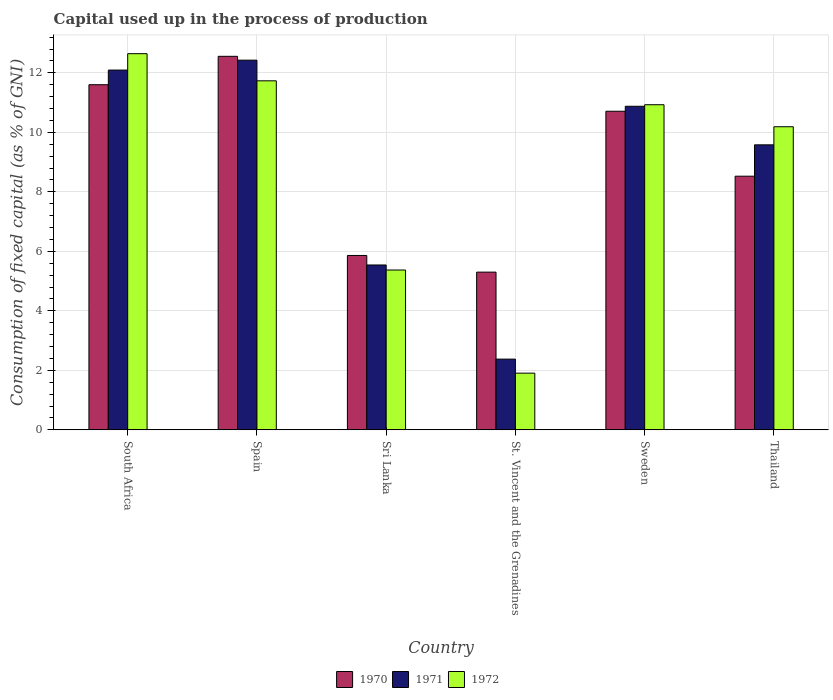How many different coloured bars are there?
Provide a succinct answer. 3. Are the number of bars per tick equal to the number of legend labels?
Ensure brevity in your answer.  Yes. Are the number of bars on each tick of the X-axis equal?
Your response must be concise. Yes. How many bars are there on the 3rd tick from the left?
Keep it short and to the point. 3. What is the label of the 1st group of bars from the left?
Provide a short and direct response. South Africa. In how many cases, is the number of bars for a given country not equal to the number of legend labels?
Your answer should be compact. 0. What is the capital used up in the process of production in 1971 in Sweden?
Give a very brief answer. 10.88. Across all countries, what is the maximum capital used up in the process of production in 1971?
Your answer should be compact. 12.43. Across all countries, what is the minimum capital used up in the process of production in 1970?
Ensure brevity in your answer.  5.3. In which country was the capital used up in the process of production in 1972 maximum?
Ensure brevity in your answer.  South Africa. In which country was the capital used up in the process of production in 1971 minimum?
Your response must be concise. St. Vincent and the Grenadines. What is the total capital used up in the process of production in 1971 in the graph?
Your response must be concise. 52.9. What is the difference between the capital used up in the process of production in 1972 in Spain and that in Thailand?
Give a very brief answer. 1.54. What is the difference between the capital used up in the process of production in 1971 in St. Vincent and the Grenadines and the capital used up in the process of production in 1972 in South Africa?
Your answer should be compact. -10.27. What is the average capital used up in the process of production in 1970 per country?
Your response must be concise. 9.09. What is the difference between the capital used up in the process of production of/in 1970 and capital used up in the process of production of/in 1972 in Sweden?
Offer a very short reply. -0.22. In how many countries, is the capital used up in the process of production in 1970 greater than 12.4 %?
Offer a terse response. 1. What is the ratio of the capital used up in the process of production in 1970 in Spain to that in Sweden?
Your answer should be very brief. 1.17. Is the difference between the capital used up in the process of production in 1970 in Sweden and Thailand greater than the difference between the capital used up in the process of production in 1972 in Sweden and Thailand?
Provide a succinct answer. Yes. What is the difference between the highest and the second highest capital used up in the process of production in 1972?
Provide a short and direct response. -0.8. What is the difference between the highest and the lowest capital used up in the process of production in 1970?
Ensure brevity in your answer.  7.26. What does the 2nd bar from the right in Sri Lanka represents?
Your answer should be compact. 1971. Is it the case that in every country, the sum of the capital used up in the process of production in 1970 and capital used up in the process of production in 1972 is greater than the capital used up in the process of production in 1971?
Ensure brevity in your answer.  Yes. Are all the bars in the graph horizontal?
Offer a very short reply. No. How many countries are there in the graph?
Ensure brevity in your answer.  6. What is the difference between two consecutive major ticks on the Y-axis?
Keep it short and to the point. 2. Where does the legend appear in the graph?
Your answer should be very brief. Bottom center. What is the title of the graph?
Your answer should be compact. Capital used up in the process of production. Does "1960" appear as one of the legend labels in the graph?
Make the answer very short. No. What is the label or title of the X-axis?
Offer a very short reply. Country. What is the label or title of the Y-axis?
Your answer should be very brief. Consumption of fixed capital (as % of GNI). What is the Consumption of fixed capital (as % of GNI) of 1970 in South Africa?
Keep it short and to the point. 11.6. What is the Consumption of fixed capital (as % of GNI) in 1971 in South Africa?
Your response must be concise. 12.09. What is the Consumption of fixed capital (as % of GNI) in 1972 in South Africa?
Provide a succinct answer. 12.65. What is the Consumption of fixed capital (as % of GNI) in 1970 in Spain?
Your response must be concise. 12.56. What is the Consumption of fixed capital (as % of GNI) of 1971 in Spain?
Offer a very short reply. 12.43. What is the Consumption of fixed capital (as % of GNI) in 1972 in Spain?
Provide a short and direct response. 11.73. What is the Consumption of fixed capital (as % of GNI) in 1970 in Sri Lanka?
Your answer should be compact. 5.86. What is the Consumption of fixed capital (as % of GNI) in 1971 in Sri Lanka?
Provide a succinct answer. 5.54. What is the Consumption of fixed capital (as % of GNI) in 1972 in Sri Lanka?
Provide a short and direct response. 5.37. What is the Consumption of fixed capital (as % of GNI) of 1970 in St. Vincent and the Grenadines?
Your answer should be compact. 5.3. What is the Consumption of fixed capital (as % of GNI) in 1971 in St. Vincent and the Grenadines?
Ensure brevity in your answer.  2.38. What is the Consumption of fixed capital (as % of GNI) in 1972 in St. Vincent and the Grenadines?
Your answer should be compact. 1.9. What is the Consumption of fixed capital (as % of GNI) of 1970 in Sweden?
Offer a terse response. 10.71. What is the Consumption of fixed capital (as % of GNI) of 1971 in Sweden?
Your answer should be compact. 10.88. What is the Consumption of fixed capital (as % of GNI) in 1972 in Sweden?
Ensure brevity in your answer.  10.93. What is the Consumption of fixed capital (as % of GNI) of 1970 in Thailand?
Offer a terse response. 8.53. What is the Consumption of fixed capital (as % of GNI) in 1971 in Thailand?
Your response must be concise. 9.58. What is the Consumption of fixed capital (as % of GNI) in 1972 in Thailand?
Keep it short and to the point. 10.19. Across all countries, what is the maximum Consumption of fixed capital (as % of GNI) of 1970?
Keep it short and to the point. 12.56. Across all countries, what is the maximum Consumption of fixed capital (as % of GNI) in 1971?
Provide a short and direct response. 12.43. Across all countries, what is the maximum Consumption of fixed capital (as % of GNI) of 1972?
Ensure brevity in your answer.  12.65. Across all countries, what is the minimum Consumption of fixed capital (as % of GNI) in 1970?
Your answer should be very brief. 5.3. Across all countries, what is the minimum Consumption of fixed capital (as % of GNI) in 1971?
Your answer should be compact. 2.38. Across all countries, what is the minimum Consumption of fixed capital (as % of GNI) in 1972?
Offer a terse response. 1.9. What is the total Consumption of fixed capital (as % of GNI) of 1970 in the graph?
Make the answer very short. 54.56. What is the total Consumption of fixed capital (as % of GNI) in 1971 in the graph?
Offer a terse response. 52.9. What is the total Consumption of fixed capital (as % of GNI) of 1972 in the graph?
Keep it short and to the point. 52.77. What is the difference between the Consumption of fixed capital (as % of GNI) of 1970 in South Africa and that in Spain?
Your answer should be very brief. -0.95. What is the difference between the Consumption of fixed capital (as % of GNI) of 1971 in South Africa and that in Spain?
Ensure brevity in your answer.  -0.33. What is the difference between the Consumption of fixed capital (as % of GNI) in 1972 in South Africa and that in Spain?
Make the answer very short. 0.91. What is the difference between the Consumption of fixed capital (as % of GNI) in 1970 in South Africa and that in Sri Lanka?
Ensure brevity in your answer.  5.74. What is the difference between the Consumption of fixed capital (as % of GNI) of 1971 in South Africa and that in Sri Lanka?
Offer a terse response. 6.55. What is the difference between the Consumption of fixed capital (as % of GNI) of 1972 in South Africa and that in Sri Lanka?
Keep it short and to the point. 7.27. What is the difference between the Consumption of fixed capital (as % of GNI) in 1970 in South Africa and that in St. Vincent and the Grenadines?
Offer a very short reply. 6.3. What is the difference between the Consumption of fixed capital (as % of GNI) of 1971 in South Africa and that in St. Vincent and the Grenadines?
Offer a very short reply. 9.72. What is the difference between the Consumption of fixed capital (as % of GNI) of 1972 in South Africa and that in St. Vincent and the Grenadines?
Provide a succinct answer. 10.74. What is the difference between the Consumption of fixed capital (as % of GNI) in 1970 in South Africa and that in Sweden?
Your answer should be compact. 0.89. What is the difference between the Consumption of fixed capital (as % of GNI) in 1971 in South Africa and that in Sweden?
Provide a short and direct response. 1.22. What is the difference between the Consumption of fixed capital (as % of GNI) of 1972 in South Africa and that in Sweden?
Keep it short and to the point. 1.72. What is the difference between the Consumption of fixed capital (as % of GNI) of 1970 in South Africa and that in Thailand?
Provide a succinct answer. 3.08. What is the difference between the Consumption of fixed capital (as % of GNI) in 1971 in South Africa and that in Thailand?
Keep it short and to the point. 2.51. What is the difference between the Consumption of fixed capital (as % of GNI) of 1972 in South Africa and that in Thailand?
Your answer should be very brief. 2.46. What is the difference between the Consumption of fixed capital (as % of GNI) of 1970 in Spain and that in Sri Lanka?
Make the answer very short. 6.7. What is the difference between the Consumption of fixed capital (as % of GNI) in 1971 in Spain and that in Sri Lanka?
Make the answer very short. 6.89. What is the difference between the Consumption of fixed capital (as % of GNI) of 1972 in Spain and that in Sri Lanka?
Provide a short and direct response. 6.36. What is the difference between the Consumption of fixed capital (as % of GNI) of 1970 in Spain and that in St. Vincent and the Grenadines?
Offer a terse response. 7.26. What is the difference between the Consumption of fixed capital (as % of GNI) of 1971 in Spain and that in St. Vincent and the Grenadines?
Provide a short and direct response. 10.05. What is the difference between the Consumption of fixed capital (as % of GNI) in 1972 in Spain and that in St. Vincent and the Grenadines?
Your answer should be very brief. 9.83. What is the difference between the Consumption of fixed capital (as % of GNI) in 1970 in Spain and that in Sweden?
Your answer should be very brief. 1.85. What is the difference between the Consumption of fixed capital (as % of GNI) of 1971 in Spain and that in Sweden?
Give a very brief answer. 1.55. What is the difference between the Consumption of fixed capital (as % of GNI) in 1972 in Spain and that in Sweden?
Give a very brief answer. 0.8. What is the difference between the Consumption of fixed capital (as % of GNI) of 1970 in Spain and that in Thailand?
Provide a short and direct response. 4.03. What is the difference between the Consumption of fixed capital (as % of GNI) of 1971 in Spain and that in Thailand?
Make the answer very short. 2.85. What is the difference between the Consumption of fixed capital (as % of GNI) of 1972 in Spain and that in Thailand?
Give a very brief answer. 1.54. What is the difference between the Consumption of fixed capital (as % of GNI) in 1970 in Sri Lanka and that in St. Vincent and the Grenadines?
Make the answer very short. 0.56. What is the difference between the Consumption of fixed capital (as % of GNI) in 1971 in Sri Lanka and that in St. Vincent and the Grenadines?
Offer a terse response. 3.16. What is the difference between the Consumption of fixed capital (as % of GNI) of 1972 in Sri Lanka and that in St. Vincent and the Grenadines?
Keep it short and to the point. 3.47. What is the difference between the Consumption of fixed capital (as % of GNI) in 1970 in Sri Lanka and that in Sweden?
Your response must be concise. -4.85. What is the difference between the Consumption of fixed capital (as % of GNI) in 1971 in Sri Lanka and that in Sweden?
Offer a very short reply. -5.34. What is the difference between the Consumption of fixed capital (as % of GNI) in 1972 in Sri Lanka and that in Sweden?
Your response must be concise. -5.56. What is the difference between the Consumption of fixed capital (as % of GNI) of 1970 in Sri Lanka and that in Thailand?
Provide a succinct answer. -2.67. What is the difference between the Consumption of fixed capital (as % of GNI) in 1971 in Sri Lanka and that in Thailand?
Your answer should be very brief. -4.04. What is the difference between the Consumption of fixed capital (as % of GNI) in 1972 in Sri Lanka and that in Thailand?
Make the answer very short. -4.82. What is the difference between the Consumption of fixed capital (as % of GNI) in 1970 in St. Vincent and the Grenadines and that in Sweden?
Keep it short and to the point. -5.41. What is the difference between the Consumption of fixed capital (as % of GNI) of 1971 in St. Vincent and the Grenadines and that in Sweden?
Your response must be concise. -8.5. What is the difference between the Consumption of fixed capital (as % of GNI) of 1972 in St. Vincent and the Grenadines and that in Sweden?
Offer a terse response. -9.02. What is the difference between the Consumption of fixed capital (as % of GNI) of 1970 in St. Vincent and the Grenadines and that in Thailand?
Ensure brevity in your answer.  -3.23. What is the difference between the Consumption of fixed capital (as % of GNI) of 1971 in St. Vincent and the Grenadines and that in Thailand?
Your answer should be very brief. -7.2. What is the difference between the Consumption of fixed capital (as % of GNI) in 1972 in St. Vincent and the Grenadines and that in Thailand?
Keep it short and to the point. -8.28. What is the difference between the Consumption of fixed capital (as % of GNI) of 1970 in Sweden and that in Thailand?
Provide a short and direct response. 2.18. What is the difference between the Consumption of fixed capital (as % of GNI) in 1971 in Sweden and that in Thailand?
Provide a succinct answer. 1.3. What is the difference between the Consumption of fixed capital (as % of GNI) of 1972 in Sweden and that in Thailand?
Your answer should be very brief. 0.74. What is the difference between the Consumption of fixed capital (as % of GNI) of 1970 in South Africa and the Consumption of fixed capital (as % of GNI) of 1971 in Spain?
Make the answer very short. -0.83. What is the difference between the Consumption of fixed capital (as % of GNI) of 1970 in South Africa and the Consumption of fixed capital (as % of GNI) of 1972 in Spain?
Ensure brevity in your answer.  -0.13. What is the difference between the Consumption of fixed capital (as % of GNI) in 1971 in South Africa and the Consumption of fixed capital (as % of GNI) in 1972 in Spain?
Your response must be concise. 0.36. What is the difference between the Consumption of fixed capital (as % of GNI) of 1970 in South Africa and the Consumption of fixed capital (as % of GNI) of 1971 in Sri Lanka?
Offer a terse response. 6.06. What is the difference between the Consumption of fixed capital (as % of GNI) in 1970 in South Africa and the Consumption of fixed capital (as % of GNI) in 1972 in Sri Lanka?
Provide a succinct answer. 6.23. What is the difference between the Consumption of fixed capital (as % of GNI) of 1971 in South Africa and the Consumption of fixed capital (as % of GNI) of 1972 in Sri Lanka?
Your answer should be compact. 6.72. What is the difference between the Consumption of fixed capital (as % of GNI) in 1970 in South Africa and the Consumption of fixed capital (as % of GNI) in 1971 in St. Vincent and the Grenadines?
Offer a very short reply. 9.23. What is the difference between the Consumption of fixed capital (as % of GNI) in 1970 in South Africa and the Consumption of fixed capital (as % of GNI) in 1972 in St. Vincent and the Grenadines?
Provide a succinct answer. 9.7. What is the difference between the Consumption of fixed capital (as % of GNI) of 1971 in South Africa and the Consumption of fixed capital (as % of GNI) of 1972 in St. Vincent and the Grenadines?
Offer a very short reply. 10.19. What is the difference between the Consumption of fixed capital (as % of GNI) in 1970 in South Africa and the Consumption of fixed capital (as % of GNI) in 1971 in Sweden?
Your answer should be very brief. 0.72. What is the difference between the Consumption of fixed capital (as % of GNI) of 1970 in South Africa and the Consumption of fixed capital (as % of GNI) of 1972 in Sweden?
Ensure brevity in your answer.  0.67. What is the difference between the Consumption of fixed capital (as % of GNI) in 1971 in South Africa and the Consumption of fixed capital (as % of GNI) in 1972 in Sweden?
Give a very brief answer. 1.17. What is the difference between the Consumption of fixed capital (as % of GNI) of 1970 in South Africa and the Consumption of fixed capital (as % of GNI) of 1971 in Thailand?
Your answer should be compact. 2.02. What is the difference between the Consumption of fixed capital (as % of GNI) in 1970 in South Africa and the Consumption of fixed capital (as % of GNI) in 1972 in Thailand?
Offer a terse response. 1.41. What is the difference between the Consumption of fixed capital (as % of GNI) in 1971 in South Africa and the Consumption of fixed capital (as % of GNI) in 1972 in Thailand?
Your response must be concise. 1.91. What is the difference between the Consumption of fixed capital (as % of GNI) of 1970 in Spain and the Consumption of fixed capital (as % of GNI) of 1971 in Sri Lanka?
Give a very brief answer. 7.01. What is the difference between the Consumption of fixed capital (as % of GNI) in 1970 in Spain and the Consumption of fixed capital (as % of GNI) in 1972 in Sri Lanka?
Make the answer very short. 7.18. What is the difference between the Consumption of fixed capital (as % of GNI) in 1971 in Spain and the Consumption of fixed capital (as % of GNI) in 1972 in Sri Lanka?
Provide a succinct answer. 7.06. What is the difference between the Consumption of fixed capital (as % of GNI) of 1970 in Spain and the Consumption of fixed capital (as % of GNI) of 1971 in St. Vincent and the Grenadines?
Ensure brevity in your answer.  10.18. What is the difference between the Consumption of fixed capital (as % of GNI) in 1970 in Spain and the Consumption of fixed capital (as % of GNI) in 1972 in St. Vincent and the Grenadines?
Keep it short and to the point. 10.65. What is the difference between the Consumption of fixed capital (as % of GNI) in 1971 in Spain and the Consumption of fixed capital (as % of GNI) in 1972 in St. Vincent and the Grenadines?
Your answer should be compact. 10.52. What is the difference between the Consumption of fixed capital (as % of GNI) in 1970 in Spain and the Consumption of fixed capital (as % of GNI) in 1971 in Sweden?
Give a very brief answer. 1.68. What is the difference between the Consumption of fixed capital (as % of GNI) in 1970 in Spain and the Consumption of fixed capital (as % of GNI) in 1972 in Sweden?
Offer a terse response. 1.63. What is the difference between the Consumption of fixed capital (as % of GNI) in 1971 in Spain and the Consumption of fixed capital (as % of GNI) in 1972 in Sweden?
Give a very brief answer. 1.5. What is the difference between the Consumption of fixed capital (as % of GNI) of 1970 in Spain and the Consumption of fixed capital (as % of GNI) of 1971 in Thailand?
Offer a terse response. 2.98. What is the difference between the Consumption of fixed capital (as % of GNI) of 1970 in Spain and the Consumption of fixed capital (as % of GNI) of 1972 in Thailand?
Your response must be concise. 2.37. What is the difference between the Consumption of fixed capital (as % of GNI) of 1971 in Spain and the Consumption of fixed capital (as % of GNI) of 1972 in Thailand?
Make the answer very short. 2.24. What is the difference between the Consumption of fixed capital (as % of GNI) in 1970 in Sri Lanka and the Consumption of fixed capital (as % of GNI) in 1971 in St. Vincent and the Grenadines?
Your answer should be very brief. 3.48. What is the difference between the Consumption of fixed capital (as % of GNI) in 1970 in Sri Lanka and the Consumption of fixed capital (as % of GNI) in 1972 in St. Vincent and the Grenadines?
Provide a succinct answer. 3.96. What is the difference between the Consumption of fixed capital (as % of GNI) in 1971 in Sri Lanka and the Consumption of fixed capital (as % of GNI) in 1972 in St. Vincent and the Grenadines?
Your response must be concise. 3.64. What is the difference between the Consumption of fixed capital (as % of GNI) of 1970 in Sri Lanka and the Consumption of fixed capital (as % of GNI) of 1971 in Sweden?
Your answer should be compact. -5.02. What is the difference between the Consumption of fixed capital (as % of GNI) of 1970 in Sri Lanka and the Consumption of fixed capital (as % of GNI) of 1972 in Sweden?
Your response must be concise. -5.07. What is the difference between the Consumption of fixed capital (as % of GNI) in 1971 in Sri Lanka and the Consumption of fixed capital (as % of GNI) in 1972 in Sweden?
Your answer should be compact. -5.39. What is the difference between the Consumption of fixed capital (as % of GNI) of 1970 in Sri Lanka and the Consumption of fixed capital (as % of GNI) of 1971 in Thailand?
Keep it short and to the point. -3.72. What is the difference between the Consumption of fixed capital (as % of GNI) of 1970 in Sri Lanka and the Consumption of fixed capital (as % of GNI) of 1972 in Thailand?
Offer a very short reply. -4.33. What is the difference between the Consumption of fixed capital (as % of GNI) in 1971 in Sri Lanka and the Consumption of fixed capital (as % of GNI) in 1972 in Thailand?
Your answer should be very brief. -4.65. What is the difference between the Consumption of fixed capital (as % of GNI) in 1970 in St. Vincent and the Grenadines and the Consumption of fixed capital (as % of GNI) in 1971 in Sweden?
Your answer should be compact. -5.58. What is the difference between the Consumption of fixed capital (as % of GNI) in 1970 in St. Vincent and the Grenadines and the Consumption of fixed capital (as % of GNI) in 1972 in Sweden?
Provide a short and direct response. -5.63. What is the difference between the Consumption of fixed capital (as % of GNI) in 1971 in St. Vincent and the Grenadines and the Consumption of fixed capital (as % of GNI) in 1972 in Sweden?
Offer a very short reply. -8.55. What is the difference between the Consumption of fixed capital (as % of GNI) of 1970 in St. Vincent and the Grenadines and the Consumption of fixed capital (as % of GNI) of 1971 in Thailand?
Provide a succinct answer. -4.28. What is the difference between the Consumption of fixed capital (as % of GNI) in 1970 in St. Vincent and the Grenadines and the Consumption of fixed capital (as % of GNI) in 1972 in Thailand?
Provide a short and direct response. -4.89. What is the difference between the Consumption of fixed capital (as % of GNI) of 1971 in St. Vincent and the Grenadines and the Consumption of fixed capital (as % of GNI) of 1972 in Thailand?
Keep it short and to the point. -7.81. What is the difference between the Consumption of fixed capital (as % of GNI) in 1970 in Sweden and the Consumption of fixed capital (as % of GNI) in 1971 in Thailand?
Your response must be concise. 1.13. What is the difference between the Consumption of fixed capital (as % of GNI) in 1970 in Sweden and the Consumption of fixed capital (as % of GNI) in 1972 in Thailand?
Provide a short and direct response. 0.52. What is the difference between the Consumption of fixed capital (as % of GNI) of 1971 in Sweden and the Consumption of fixed capital (as % of GNI) of 1972 in Thailand?
Your answer should be compact. 0.69. What is the average Consumption of fixed capital (as % of GNI) of 1970 per country?
Offer a terse response. 9.09. What is the average Consumption of fixed capital (as % of GNI) of 1971 per country?
Provide a short and direct response. 8.82. What is the average Consumption of fixed capital (as % of GNI) of 1972 per country?
Provide a short and direct response. 8.8. What is the difference between the Consumption of fixed capital (as % of GNI) in 1970 and Consumption of fixed capital (as % of GNI) in 1971 in South Africa?
Offer a very short reply. -0.49. What is the difference between the Consumption of fixed capital (as % of GNI) of 1970 and Consumption of fixed capital (as % of GNI) of 1972 in South Africa?
Keep it short and to the point. -1.04. What is the difference between the Consumption of fixed capital (as % of GNI) of 1971 and Consumption of fixed capital (as % of GNI) of 1972 in South Africa?
Provide a short and direct response. -0.55. What is the difference between the Consumption of fixed capital (as % of GNI) of 1970 and Consumption of fixed capital (as % of GNI) of 1971 in Spain?
Your answer should be compact. 0.13. What is the difference between the Consumption of fixed capital (as % of GNI) in 1970 and Consumption of fixed capital (as % of GNI) in 1972 in Spain?
Your response must be concise. 0.82. What is the difference between the Consumption of fixed capital (as % of GNI) of 1971 and Consumption of fixed capital (as % of GNI) of 1972 in Spain?
Provide a succinct answer. 0.69. What is the difference between the Consumption of fixed capital (as % of GNI) in 1970 and Consumption of fixed capital (as % of GNI) in 1971 in Sri Lanka?
Keep it short and to the point. 0.32. What is the difference between the Consumption of fixed capital (as % of GNI) of 1970 and Consumption of fixed capital (as % of GNI) of 1972 in Sri Lanka?
Your response must be concise. 0.49. What is the difference between the Consumption of fixed capital (as % of GNI) in 1971 and Consumption of fixed capital (as % of GNI) in 1972 in Sri Lanka?
Provide a short and direct response. 0.17. What is the difference between the Consumption of fixed capital (as % of GNI) of 1970 and Consumption of fixed capital (as % of GNI) of 1971 in St. Vincent and the Grenadines?
Ensure brevity in your answer.  2.92. What is the difference between the Consumption of fixed capital (as % of GNI) of 1970 and Consumption of fixed capital (as % of GNI) of 1972 in St. Vincent and the Grenadines?
Provide a short and direct response. 3.4. What is the difference between the Consumption of fixed capital (as % of GNI) of 1971 and Consumption of fixed capital (as % of GNI) of 1972 in St. Vincent and the Grenadines?
Your response must be concise. 0.47. What is the difference between the Consumption of fixed capital (as % of GNI) in 1970 and Consumption of fixed capital (as % of GNI) in 1971 in Sweden?
Make the answer very short. -0.17. What is the difference between the Consumption of fixed capital (as % of GNI) of 1970 and Consumption of fixed capital (as % of GNI) of 1972 in Sweden?
Your answer should be very brief. -0.22. What is the difference between the Consumption of fixed capital (as % of GNI) of 1971 and Consumption of fixed capital (as % of GNI) of 1972 in Sweden?
Your answer should be very brief. -0.05. What is the difference between the Consumption of fixed capital (as % of GNI) in 1970 and Consumption of fixed capital (as % of GNI) in 1971 in Thailand?
Ensure brevity in your answer.  -1.05. What is the difference between the Consumption of fixed capital (as % of GNI) in 1970 and Consumption of fixed capital (as % of GNI) in 1972 in Thailand?
Your answer should be compact. -1.66. What is the difference between the Consumption of fixed capital (as % of GNI) of 1971 and Consumption of fixed capital (as % of GNI) of 1972 in Thailand?
Ensure brevity in your answer.  -0.61. What is the ratio of the Consumption of fixed capital (as % of GNI) in 1970 in South Africa to that in Spain?
Ensure brevity in your answer.  0.92. What is the ratio of the Consumption of fixed capital (as % of GNI) in 1971 in South Africa to that in Spain?
Keep it short and to the point. 0.97. What is the ratio of the Consumption of fixed capital (as % of GNI) of 1972 in South Africa to that in Spain?
Make the answer very short. 1.08. What is the ratio of the Consumption of fixed capital (as % of GNI) of 1970 in South Africa to that in Sri Lanka?
Offer a terse response. 1.98. What is the ratio of the Consumption of fixed capital (as % of GNI) of 1971 in South Africa to that in Sri Lanka?
Ensure brevity in your answer.  2.18. What is the ratio of the Consumption of fixed capital (as % of GNI) of 1972 in South Africa to that in Sri Lanka?
Keep it short and to the point. 2.35. What is the ratio of the Consumption of fixed capital (as % of GNI) of 1970 in South Africa to that in St. Vincent and the Grenadines?
Your answer should be very brief. 2.19. What is the ratio of the Consumption of fixed capital (as % of GNI) in 1971 in South Africa to that in St. Vincent and the Grenadines?
Provide a succinct answer. 5.09. What is the ratio of the Consumption of fixed capital (as % of GNI) of 1972 in South Africa to that in St. Vincent and the Grenadines?
Offer a terse response. 6.64. What is the ratio of the Consumption of fixed capital (as % of GNI) in 1970 in South Africa to that in Sweden?
Ensure brevity in your answer.  1.08. What is the ratio of the Consumption of fixed capital (as % of GNI) in 1971 in South Africa to that in Sweden?
Make the answer very short. 1.11. What is the ratio of the Consumption of fixed capital (as % of GNI) in 1972 in South Africa to that in Sweden?
Provide a short and direct response. 1.16. What is the ratio of the Consumption of fixed capital (as % of GNI) in 1970 in South Africa to that in Thailand?
Your answer should be very brief. 1.36. What is the ratio of the Consumption of fixed capital (as % of GNI) of 1971 in South Africa to that in Thailand?
Offer a very short reply. 1.26. What is the ratio of the Consumption of fixed capital (as % of GNI) of 1972 in South Africa to that in Thailand?
Ensure brevity in your answer.  1.24. What is the ratio of the Consumption of fixed capital (as % of GNI) in 1970 in Spain to that in Sri Lanka?
Provide a short and direct response. 2.14. What is the ratio of the Consumption of fixed capital (as % of GNI) in 1971 in Spain to that in Sri Lanka?
Provide a short and direct response. 2.24. What is the ratio of the Consumption of fixed capital (as % of GNI) in 1972 in Spain to that in Sri Lanka?
Keep it short and to the point. 2.18. What is the ratio of the Consumption of fixed capital (as % of GNI) of 1970 in Spain to that in St. Vincent and the Grenadines?
Make the answer very short. 2.37. What is the ratio of the Consumption of fixed capital (as % of GNI) in 1971 in Spain to that in St. Vincent and the Grenadines?
Your answer should be very brief. 5.23. What is the ratio of the Consumption of fixed capital (as % of GNI) in 1972 in Spain to that in St. Vincent and the Grenadines?
Make the answer very short. 6.16. What is the ratio of the Consumption of fixed capital (as % of GNI) of 1970 in Spain to that in Sweden?
Give a very brief answer. 1.17. What is the ratio of the Consumption of fixed capital (as % of GNI) of 1971 in Spain to that in Sweden?
Offer a terse response. 1.14. What is the ratio of the Consumption of fixed capital (as % of GNI) of 1972 in Spain to that in Sweden?
Your answer should be very brief. 1.07. What is the ratio of the Consumption of fixed capital (as % of GNI) of 1970 in Spain to that in Thailand?
Your response must be concise. 1.47. What is the ratio of the Consumption of fixed capital (as % of GNI) in 1971 in Spain to that in Thailand?
Your response must be concise. 1.3. What is the ratio of the Consumption of fixed capital (as % of GNI) in 1972 in Spain to that in Thailand?
Provide a succinct answer. 1.15. What is the ratio of the Consumption of fixed capital (as % of GNI) of 1970 in Sri Lanka to that in St. Vincent and the Grenadines?
Your answer should be compact. 1.11. What is the ratio of the Consumption of fixed capital (as % of GNI) in 1971 in Sri Lanka to that in St. Vincent and the Grenadines?
Your response must be concise. 2.33. What is the ratio of the Consumption of fixed capital (as % of GNI) in 1972 in Sri Lanka to that in St. Vincent and the Grenadines?
Offer a terse response. 2.82. What is the ratio of the Consumption of fixed capital (as % of GNI) in 1970 in Sri Lanka to that in Sweden?
Give a very brief answer. 0.55. What is the ratio of the Consumption of fixed capital (as % of GNI) of 1971 in Sri Lanka to that in Sweden?
Keep it short and to the point. 0.51. What is the ratio of the Consumption of fixed capital (as % of GNI) of 1972 in Sri Lanka to that in Sweden?
Ensure brevity in your answer.  0.49. What is the ratio of the Consumption of fixed capital (as % of GNI) in 1970 in Sri Lanka to that in Thailand?
Ensure brevity in your answer.  0.69. What is the ratio of the Consumption of fixed capital (as % of GNI) of 1971 in Sri Lanka to that in Thailand?
Your answer should be compact. 0.58. What is the ratio of the Consumption of fixed capital (as % of GNI) of 1972 in Sri Lanka to that in Thailand?
Offer a very short reply. 0.53. What is the ratio of the Consumption of fixed capital (as % of GNI) of 1970 in St. Vincent and the Grenadines to that in Sweden?
Ensure brevity in your answer.  0.49. What is the ratio of the Consumption of fixed capital (as % of GNI) of 1971 in St. Vincent and the Grenadines to that in Sweden?
Provide a succinct answer. 0.22. What is the ratio of the Consumption of fixed capital (as % of GNI) in 1972 in St. Vincent and the Grenadines to that in Sweden?
Ensure brevity in your answer.  0.17. What is the ratio of the Consumption of fixed capital (as % of GNI) in 1970 in St. Vincent and the Grenadines to that in Thailand?
Provide a short and direct response. 0.62. What is the ratio of the Consumption of fixed capital (as % of GNI) in 1971 in St. Vincent and the Grenadines to that in Thailand?
Give a very brief answer. 0.25. What is the ratio of the Consumption of fixed capital (as % of GNI) of 1972 in St. Vincent and the Grenadines to that in Thailand?
Make the answer very short. 0.19. What is the ratio of the Consumption of fixed capital (as % of GNI) in 1970 in Sweden to that in Thailand?
Provide a short and direct response. 1.26. What is the ratio of the Consumption of fixed capital (as % of GNI) of 1971 in Sweden to that in Thailand?
Ensure brevity in your answer.  1.14. What is the ratio of the Consumption of fixed capital (as % of GNI) of 1972 in Sweden to that in Thailand?
Your answer should be compact. 1.07. What is the difference between the highest and the second highest Consumption of fixed capital (as % of GNI) in 1970?
Your response must be concise. 0.95. What is the difference between the highest and the second highest Consumption of fixed capital (as % of GNI) in 1971?
Ensure brevity in your answer.  0.33. What is the difference between the highest and the second highest Consumption of fixed capital (as % of GNI) of 1972?
Make the answer very short. 0.91. What is the difference between the highest and the lowest Consumption of fixed capital (as % of GNI) in 1970?
Offer a terse response. 7.26. What is the difference between the highest and the lowest Consumption of fixed capital (as % of GNI) of 1971?
Make the answer very short. 10.05. What is the difference between the highest and the lowest Consumption of fixed capital (as % of GNI) of 1972?
Keep it short and to the point. 10.74. 